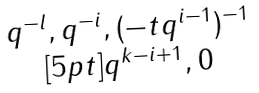<formula> <loc_0><loc_0><loc_500><loc_500>\begin{matrix} q ^ { - l } , q ^ { - i } , ( - t q ^ { i - 1 } ) ^ { - 1 } \\ [ 5 p t ] q ^ { k - i + 1 } , 0 \end{matrix}</formula> 